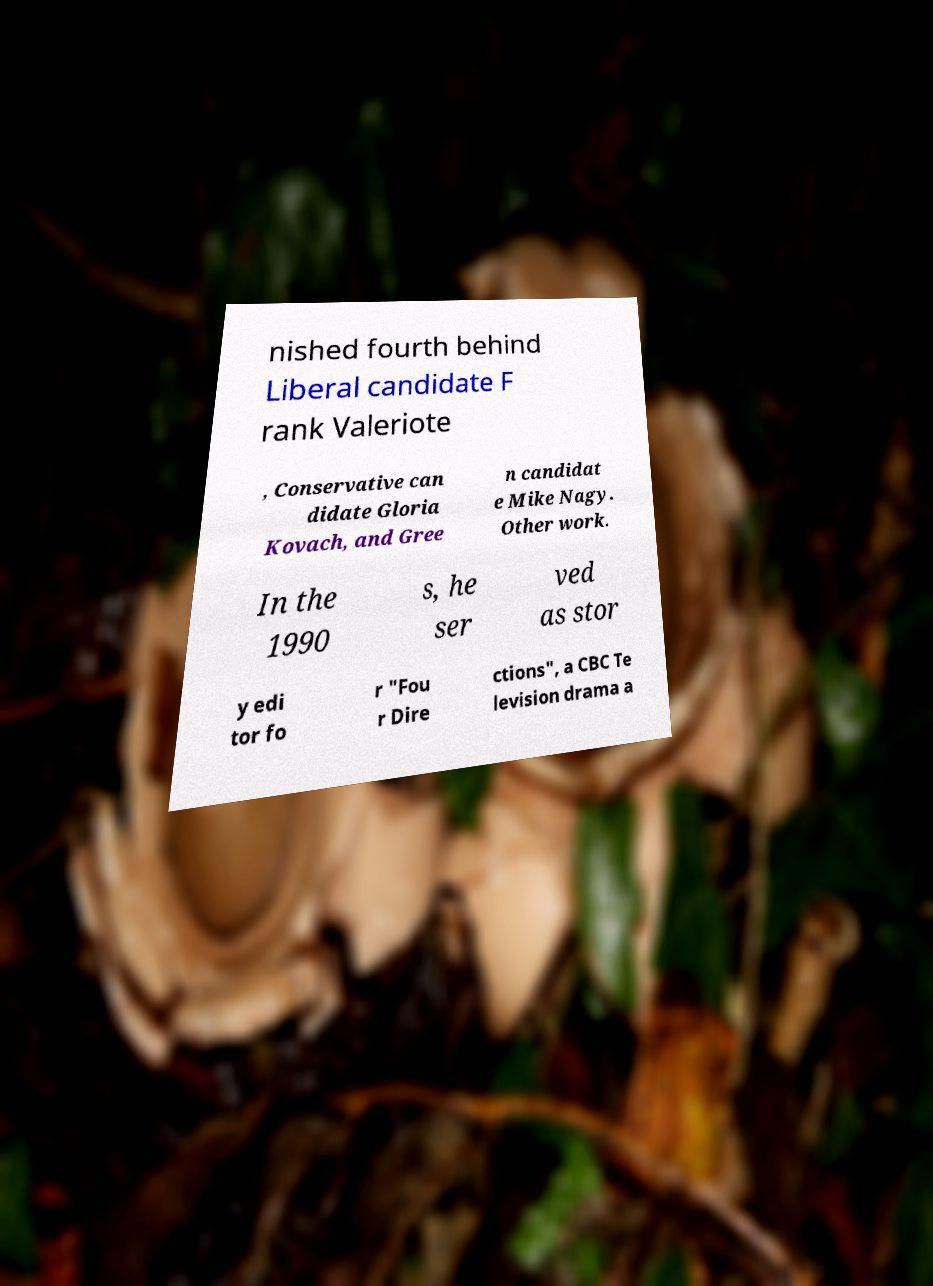Please identify and transcribe the text found in this image. nished fourth behind Liberal candidate F rank Valeriote , Conservative can didate Gloria Kovach, and Gree n candidat e Mike Nagy. Other work. In the 1990 s, he ser ved as stor y edi tor fo r "Fou r Dire ctions", a CBC Te levision drama a 